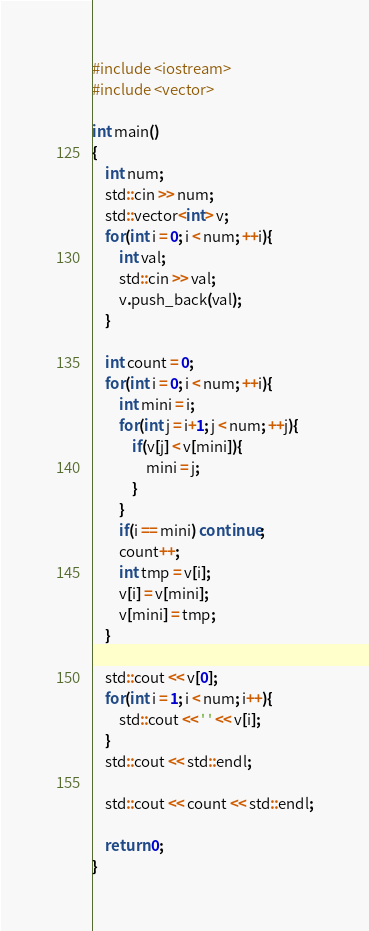<code> <loc_0><loc_0><loc_500><loc_500><_C++_>#include <iostream>
#include <vector>

int main()
{
    int num;
    std::cin >> num;
    std::vector<int> v;
    for(int i = 0; i < num; ++i){
        int val;
        std::cin >> val;
        v.push_back(val);
    }

    int count = 0;
    for(int i = 0; i < num; ++i){
        int mini = i;
        for(int j = i+1; j < num; ++j){
            if(v[j] < v[mini]){
                mini = j;
            }
        }
        if(i == mini) continue;
        count++;
        int tmp = v[i];
        v[i] = v[mini];
        v[mini] = tmp;
    }

    std::cout << v[0];
    for(int i = 1; i < num; i++){
        std::cout << ' ' << v[i];
    }
    std::cout << std::endl;

    std::cout << count << std::endl;

    return 0;
}

</code> 